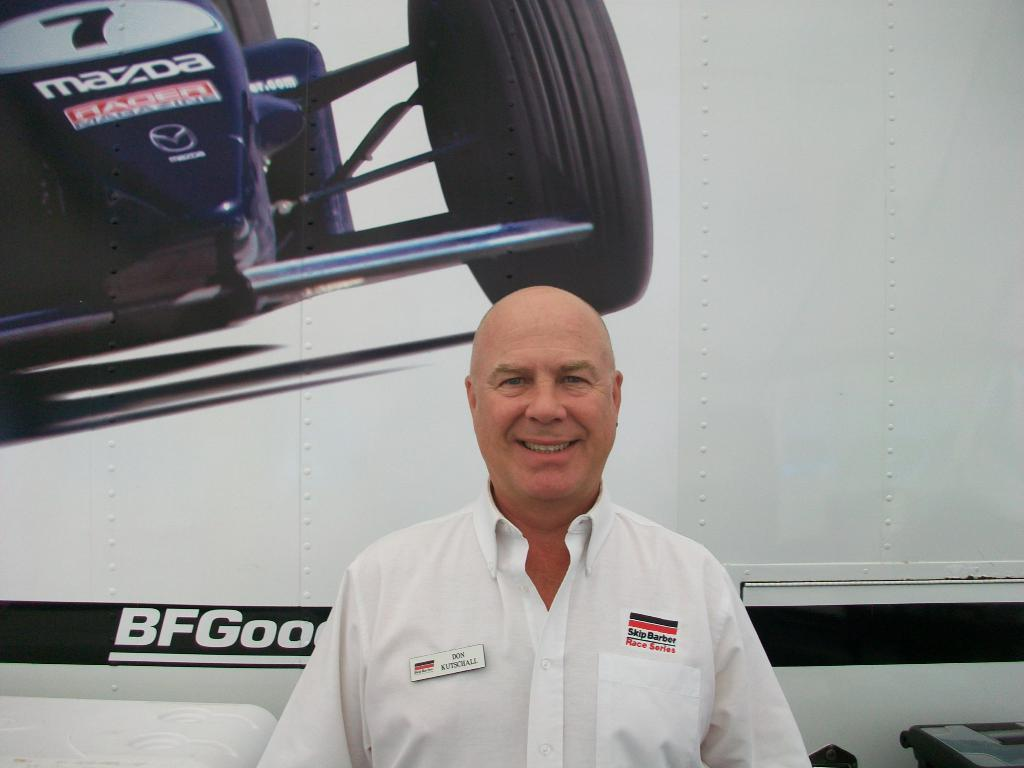<image>
Give a short and clear explanation of the subsequent image. Don Kitschall stands in front of a large picture of a race car. 